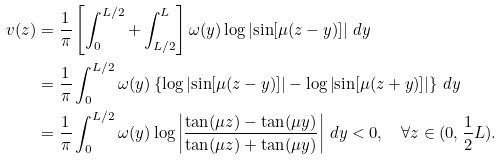Convert formula to latex. <formula><loc_0><loc_0><loc_500><loc_500>v ( z ) & = \frac { 1 } { \pi } \left [ \int _ { 0 } ^ { L / 2 } + \int _ { L / 2 } ^ { L } \right ] \omega ( y ) \log \left | \sin [ \mu ( z - y ) ] \right | \, d y \\ & = \frac { 1 } { \pi } \int _ { 0 } ^ { L / 2 } \omega ( y ) \left \{ \log \left | \sin [ \mu ( z - y ) ] \right | - \log \left | \sin [ \mu ( z + y ) ] \right | \right \} \, d y \\ & = \frac { 1 } { \pi } \int _ { 0 } ^ { L / 2 } \omega ( y ) \log \left | \frac { \tan ( \mu z ) - \tan ( \mu y ) } { \tan ( \mu z ) + \tan ( \mu y ) } \right | \, d y < 0 , \quad \forall z \in ( 0 , \frac { 1 } { 2 } L ) .</formula> 